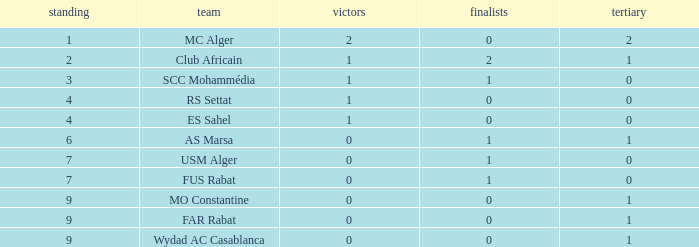How many Winners have a Third of 1, and Runners-up smaller than 0? 0.0. 